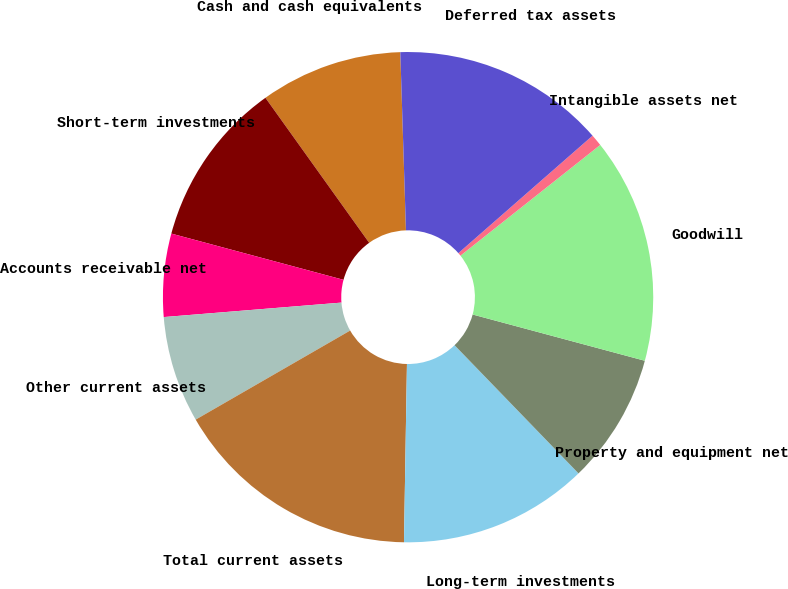Convert chart. <chart><loc_0><loc_0><loc_500><loc_500><pie_chart><fcel>Cash and cash equivalents<fcel>Short-term investments<fcel>Accounts receivable net<fcel>Other current assets<fcel>Total current assets<fcel>Long-term investments<fcel>Property and equipment net<fcel>Goodwill<fcel>Intangible assets net<fcel>Deferred tax assets<nl><fcel>9.38%<fcel>10.94%<fcel>5.47%<fcel>7.03%<fcel>16.41%<fcel>12.5%<fcel>8.59%<fcel>14.84%<fcel>0.78%<fcel>14.06%<nl></chart> 